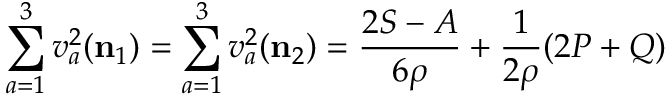Convert formula to latex. <formula><loc_0><loc_0><loc_500><loc_500>\sum _ { a = 1 } ^ { 3 } v _ { a } ^ { 2 } ( { n _ { 1 } } ) = \sum _ { a = 1 } ^ { 3 } v _ { a } ^ { 2 } ( { n _ { 2 } } ) = \frac { 2 S - A } { 6 \rho } + \frac { 1 } 2 \rho } ( 2 P + Q )</formula> 